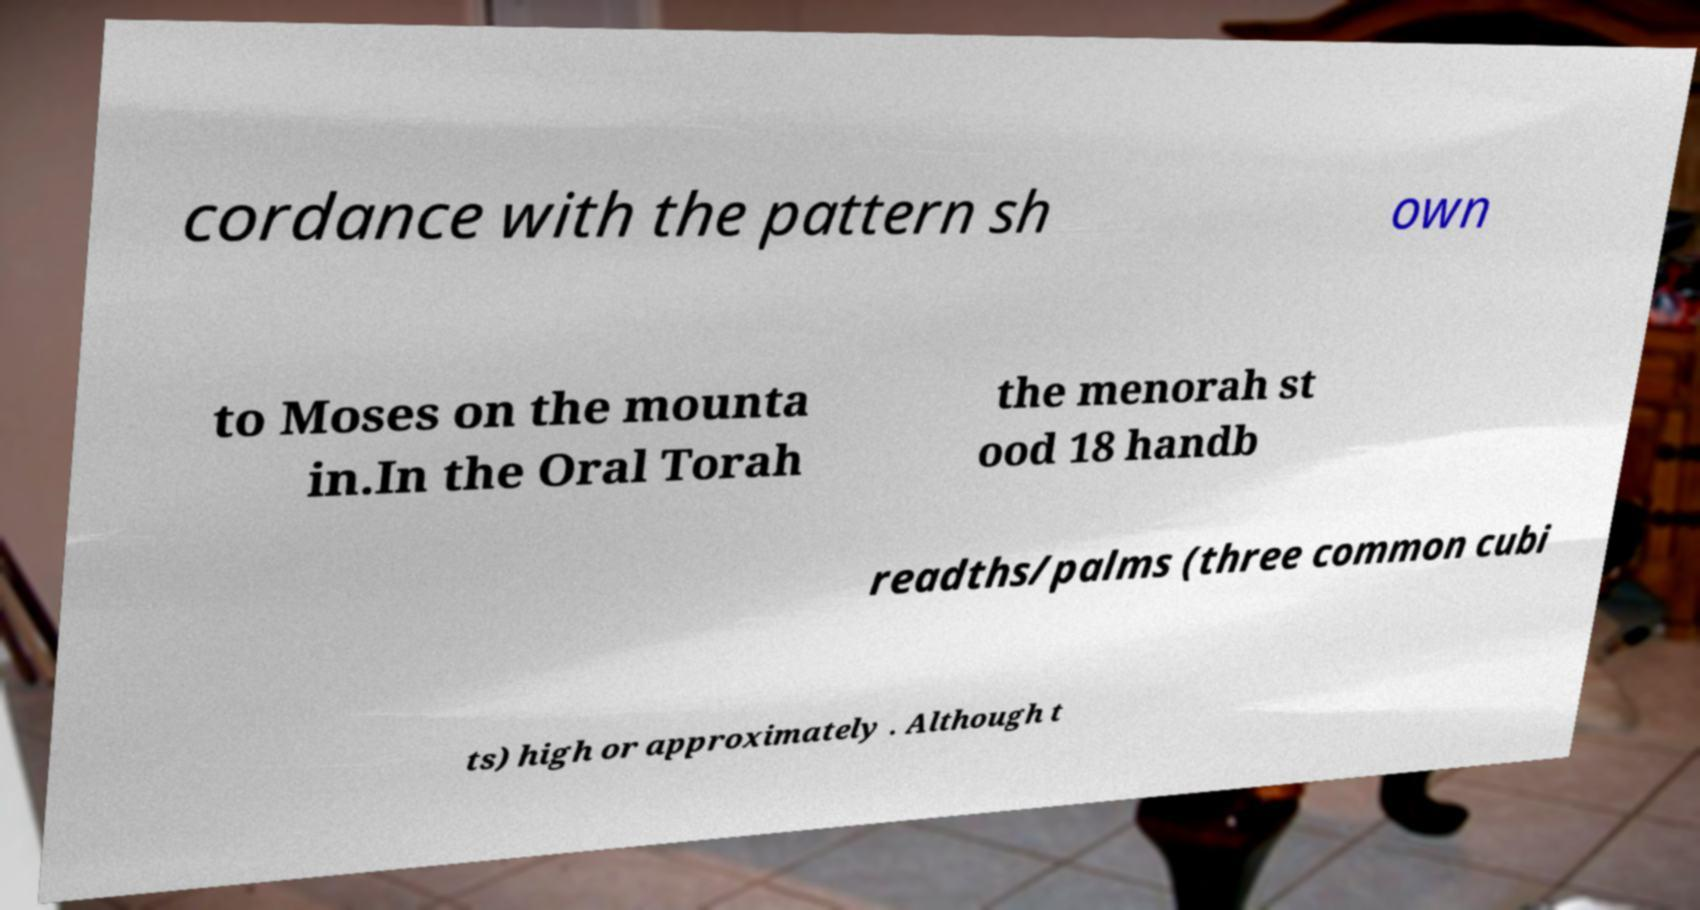Please read and relay the text visible in this image. What does it say? cordance with the pattern sh own to Moses on the mounta in.In the Oral Torah the menorah st ood 18 handb readths/palms (three common cubi ts) high or approximately . Although t 